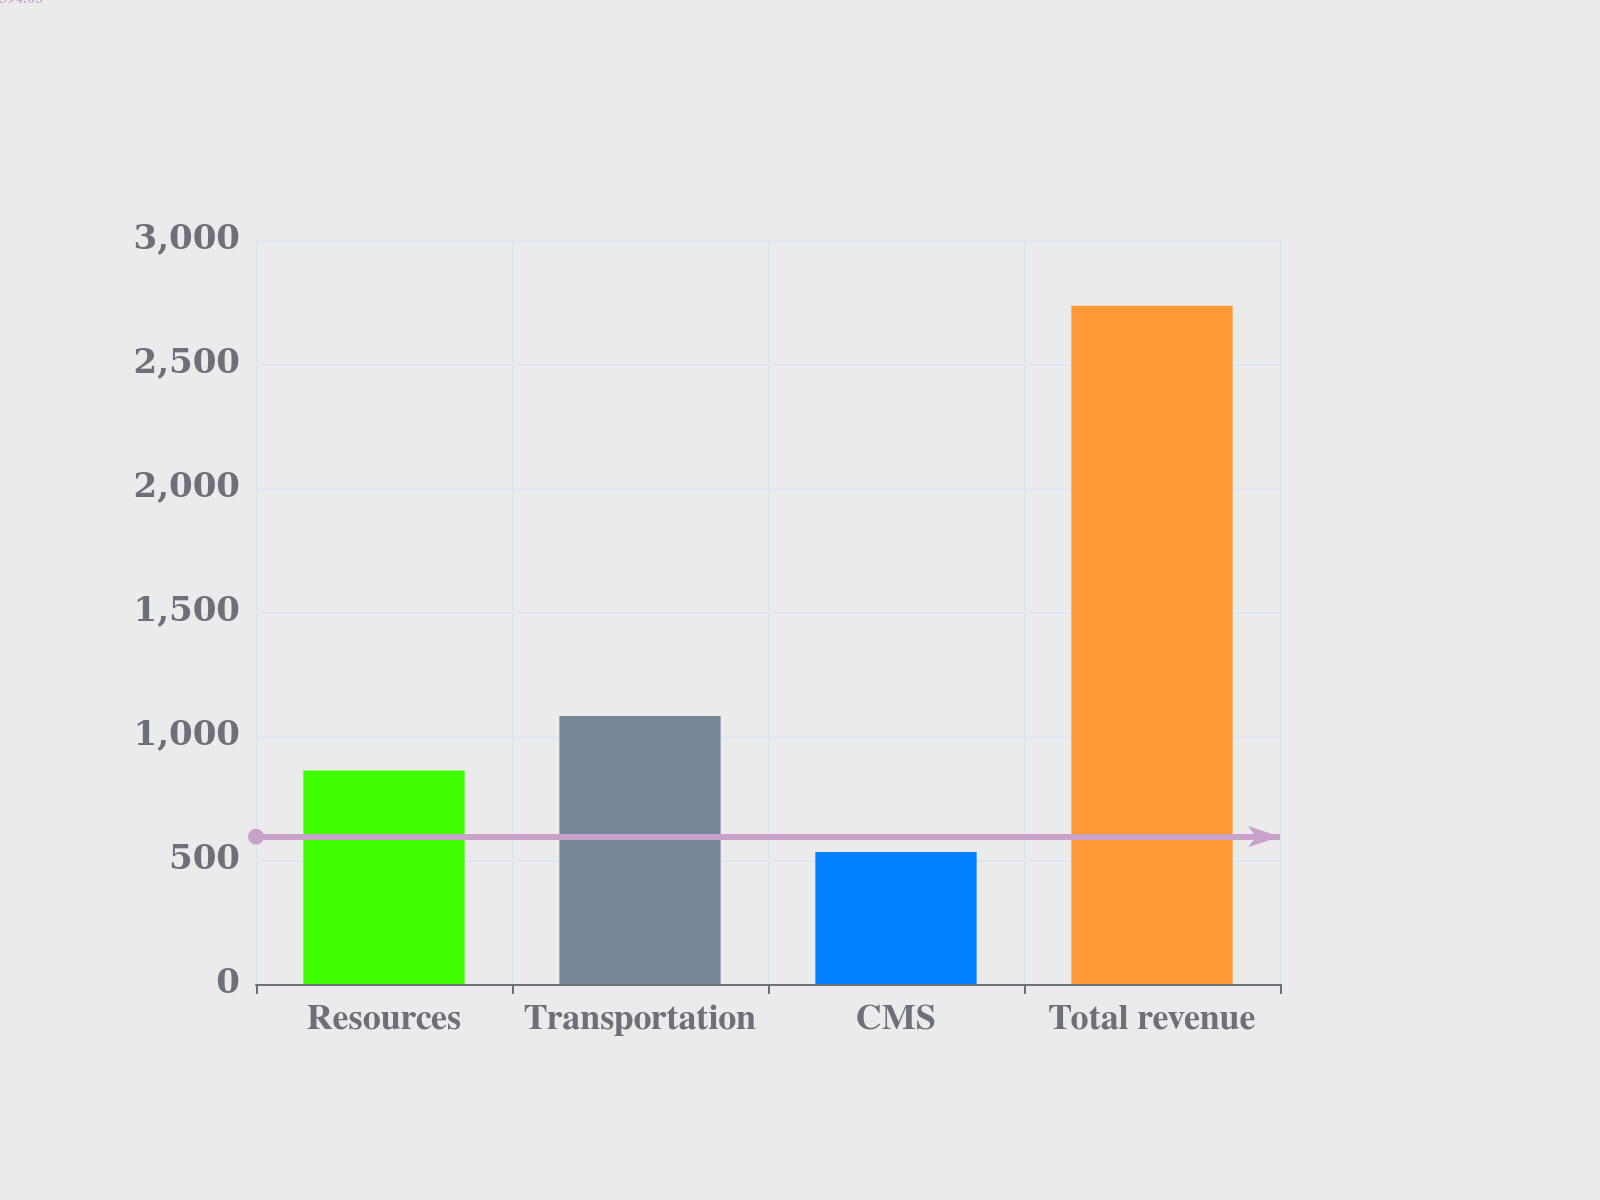<chart> <loc_0><loc_0><loc_500><loc_500><bar_chart><fcel>Resources<fcel>Transportation<fcel>CMS<fcel>Total revenue<nl><fcel>860.8<fcel>1081.06<fcel>532.2<fcel>2734.8<nl></chart> 